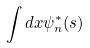Convert formula to latex. <formula><loc_0><loc_0><loc_500><loc_500>\int d x \psi _ { n } ^ { * } ( s )</formula> 